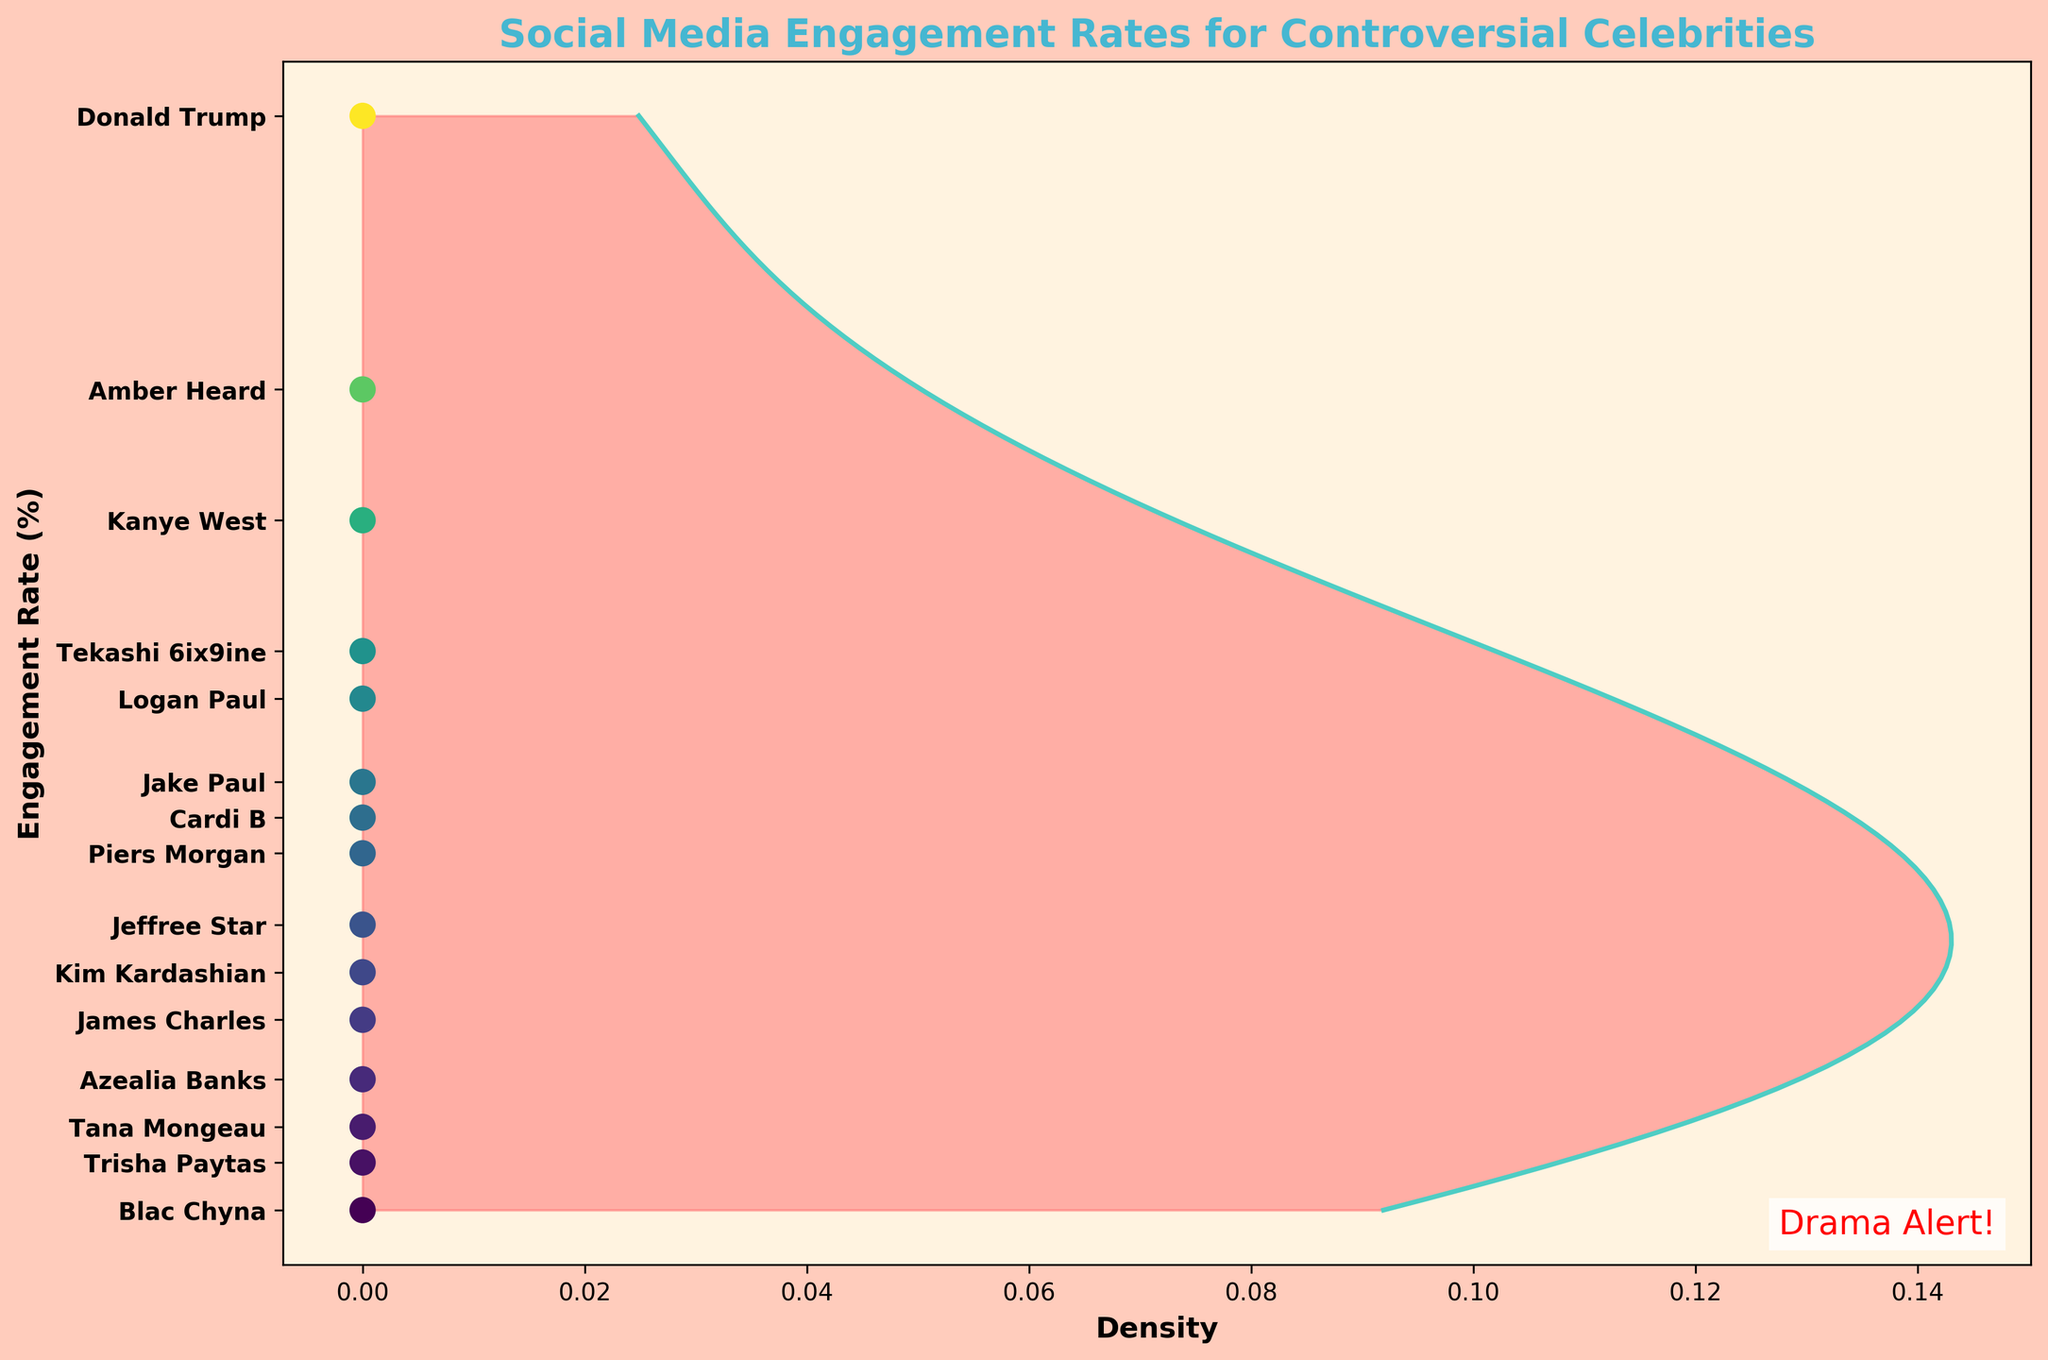What is the title of the figure? The title can be found at the top of the plot, and it reads "Social Media Engagement Rates for Controversial Celebrities."
Answer: Social Media Engagement Rates for Controversial Celebrities How are the engagement rates distributed across the celebrities? The engagement rates are shown on the vertical axis with a colored density plot filling the area under the curve and scatter points along the horizontal line at each rate.
Answer: They follow a density distribution curve with scatter points Which celebrity has the highest engagement rate? By examining the vertical axis where engagement rates are noted, Donald Trump has the highest engagement rate marked at 25.7.
Answer: Donald Trump What is the range of engagement rates covered by the plot? The range can be determined by looking at the minimum and maximum engagement rates marked on the vertical axis. They range from 16.5 to 25.7.
Answer: From 16.5 to 25.7 Compare the engagement rates of Kim Kardashian and Amber Heard. Who has a higher rate? Look at the vertical axis for both Kim Kardashian and Amber Heard. Kim is marked at 18.5, while Amber is marked at 23.4.
Answer: Amber Heard What is the background color of the plot? The background color of the plot can be noted from the visible area in the figure, which is a pale, beige-like color with a slightly reddish tint.
Answer: Pale beige with reddish tint How many celebrities have an engagement rate higher than 20%? Count the celebrities from the vertical axis with engagement rates greater than 20%; these are Kanye West, Donald Trump, Tekashi 6ix9ine, Amber Heard, and Logan Paul.
Answer: 5 celebrities Find the median engagement rate from the plotted data. To find the median, sort the engagement rates (16.5, 16.9, 17.2, 17.6, 18.1, 18.5, 18.9, 19.5, 19.8, 20.1, 20.8, 21.2, 22.3, 23.4, 25.7) and locate the middle value, which is 19.5.
Answer: 19.5 How does Jake Paul's engagement rate compare to Jeffree Star's? Check the vertical axis where Jake Paul is marked at 20.1, and Jeffree Star at 18.9. Therefore, Jake Paul's rate is higher.
Answer: Jake Paul is higher What color is used to indicate the density area in the plot? The color used to fill the density area under the curve is a semi-transparent red-pink shade seen clearly in the figure.
Answer: Red-pink 